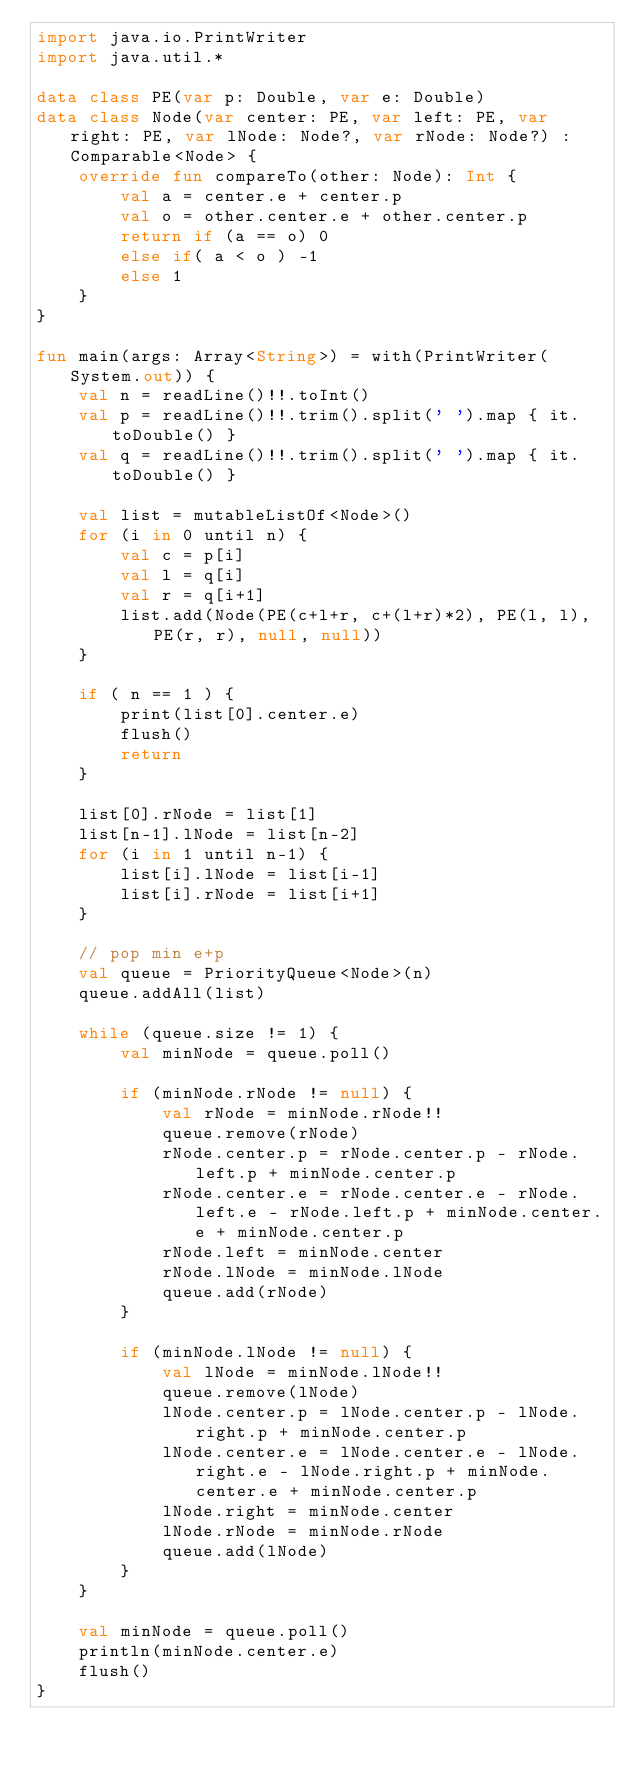Convert code to text. <code><loc_0><loc_0><loc_500><loc_500><_Kotlin_>import java.io.PrintWriter
import java.util.*

data class PE(var p: Double, var e: Double)
data class Node(var center: PE, var left: PE, var right: PE, var lNode: Node?, var rNode: Node?) : Comparable<Node> {
    override fun compareTo(other: Node): Int {
        val a = center.e + center.p
        val o = other.center.e + other.center.p
        return if (a == o) 0
        else if( a < o ) -1
        else 1
    }
}

fun main(args: Array<String>) = with(PrintWriter(System.out)) {
    val n = readLine()!!.toInt()
    val p = readLine()!!.trim().split(' ').map { it.toDouble() }
    val q = readLine()!!.trim().split(' ').map { it.toDouble() }

    val list = mutableListOf<Node>()
    for (i in 0 until n) {
        val c = p[i]
        val l = q[i]
        val r = q[i+1]
        list.add(Node(PE(c+l+r, c+(l+r)*2), PE(l, l), PE(r, r), null, null))
    }

    if ( n == 1 ) {
        print(list[0].center.e)
        flush()
        return
    }

    list[0].rNode = list[1]
    list[n-1].lNode = list[n-2]
    for (i in 1 until n-1) {
        list[i].lNode = list[i-1]
        list[i].rNode = list[i+1]
    }

    // pop min e+p
    val queue = PriorityQueue<Node>(n)
    queue.addAll(list)

    while (queue.size != 1) {
        val minNode = queue.poll()

        if (minNode.rNode != null) {
            val rNode = minNode.rNode!!
            queue.remove(rNode)
            rNode.center.p = rNode.center.p - rNode.left.p + minNode.center.p
            rNode.center.e = rNode.center.e - rNode.left.e - rNode.left.p + minNode.center.e + minNode.center.p
            rNode.left = minNode.center
            rNode.lNode = minNode.lNode
            queue.add(rNode)
        }

        if (minNode.lNode != null) {
            val lNode = minNode.lNode!!
            queue.remove(lNode)
            lNode.center.p = lNode.center.p - lNode.right.p + minNode.center.p
            lNode.center.e = lNode.center.e - lNode.right.e - lNode.right.p + minNode.center.e + minNode.center.p
            lNode.right = minNode.center
            lNode.rNode = minNode.rNode
            queue.add(lNode)
        }
    }

    val minNode = queue.poll()
    println(minNode.center.e)
    flush()
}

</code> 